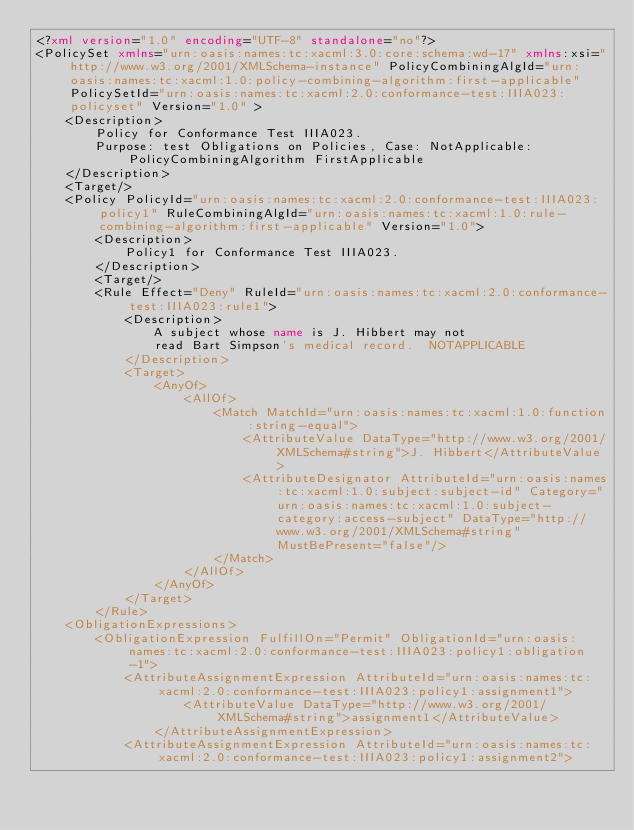Convert code to text. <code><loc_0><loc_0><loc_500><loc_500><_XML_><?xml version="1.0" encoding="UTF-8" standalone="no"?>
<PolicySet xmlns="urn:oasis:names:tc:xacml:3.0:core:schema:wd-17" xmlns:xsi="http://www.w3.org/2001/XMLSchema-instance" PolicyCombiningAlgId="urn:oasis:names:tc:xacml:1.0:policy-combining-algorithm:first-applicable" PolicySetId="urn:oasis:names:tc:xacml:2.0:conformance-test:IIIA023:policyset" Version="1.0" >
    <Description>
        Policy for Conformance Test IIIA023.
        Purpose: test Obligations on Policies, Case: NotApplicable: PolicyCombiningAlgorithm FirstApplicable    
    </Description>
    <Target/>
    <Policy PolicyId="urn:oasis:names:tc:xacml:2.0:conformance-test:IIIA023:policy1" RuleCombiningAlgId="urn:oasis:names:tc:xacml:1.0:rule-combining-algorithm:first-applicable" Version="1.0">
        <Description>
            Policy1 for Conformance Test IIIA023.
        </Description>
        <Target/>
        <Rule Effect="Deny" RuleId="urn:oasis:names:tc:xacml:2.0:conformance-test:IIIA023:rule1">
            <Description>
                A subject whose name is J. Hibbert may not
                read Bart Simpson's medical record.  NOTAPPLICABLE
            </Description>
            <Target>
                <AnyOf>
                    <AllOf>
                        <Match MatchId="urn:oasis:names:tc:xacml:1.0:function:string-equal">
                            <AttributeValue DataType="http://www.w3.org/2001/XMLSchema#string">J. Hibbert</AttributeValue>
                            <AttributeDesignator AttributeId="urn:oasis:names:tc:xacml:1.0:subject:subject-id" Category="urn:oasis:names:tc:xacml:1.0:subject-category:access-subject" DataType="http://www.w3.org/2001/XMLSchema#string" MustBePresent="false"/>
                        </Match>
                    </AllOf>
                </AnyOf>
            </Target>
        </Rule>
    <ObligationExpressions>
        <ObligationExpression FulfillOn="Permit" ObligationId="urn:oasis:names:tc:xacml:2.0:conformance-test:IIIA023:policy1:obligation-1">
            <AttributeAssignmentExpression AttributeId="urn:oasis:names:tc:xacml:2.0:conformance-test:IIIA023:policy1:assignment1">
                    <AttributeValue DataType="http://www.w3.org/2001/XMLSchema#string">assignment1</AttributeValue>
                </AttributeAssignmentExpression>
            <AttributeAssignmentExpression AttributeId="urn:oasis:names:tc:xacml:2.0:conformance-test:IIIA023:policy1:assignment2"></code> 